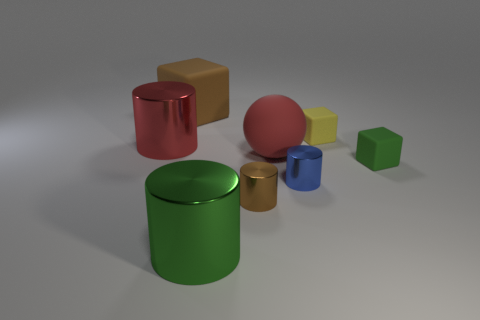Does the big block have the same color as the ball?
Your answer should be compact. No. There is a large rubber thing that is to the right of the brown metallic thing; what color is it?
Make the answer very short. Red. What material is the big cylinder that is to the right of the big red thing left of the green shiny cylinder?
Offer a very short reply. Metal. There is a brown shiny object; what shape is it?
Your answer should be very brief. Cylinder. What is the material of the brown thing that is the same shape as the green metallic object?
Provide a short and direct response. Metal. How many blue matte cylinders are the same size as the brown block?
Your answer should be very brief. 0. Is there a big red shiny thing that is behind the green object that is in front of the tiny blue metal object?
Offer a terse response. Yes. What number of brown things are either matte objects or spheres?
Make the answer very short. 1. What color is the matte sphere?
Ensure brevity in your answer.  Red. There is a green thing that is the same material as the blue cylinder; what size is it?
Ensure brevity in your answer.  Large. 